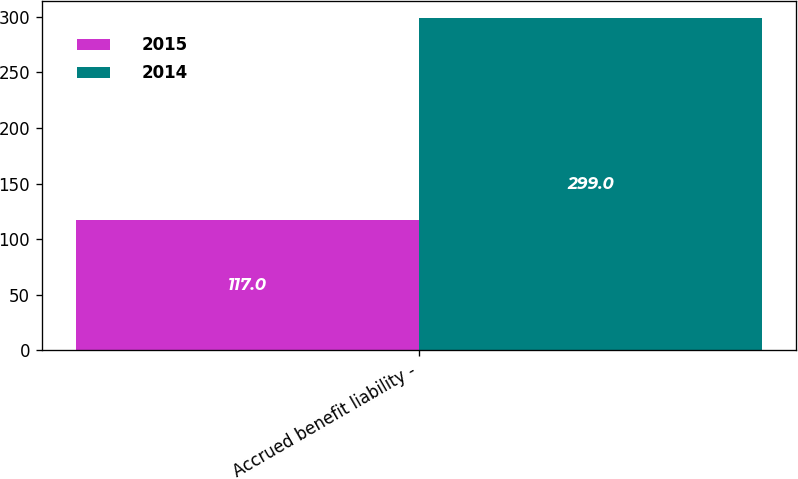Convert chart to OTSL. <chart><loc_0><loc_0><loc_500><loc_500><stacked_bar_chart><ecel><fcel>Accrued benefit liability -<nl><fcel>2015<fcel>117<nl><fcel>2014<fcel>299<nl></chart> 